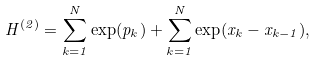<formula> <loc_0><loc_0><loc_500><loc_500>H ^ { ( 2 ) } = \sum _ { k = 1 } ^ { N } \exp ( p _ { k } ) + \sum _ { k = 1 } ^ { N } \exp ( x _ { k } - x _ { k - 1 } ) ,</formula> 